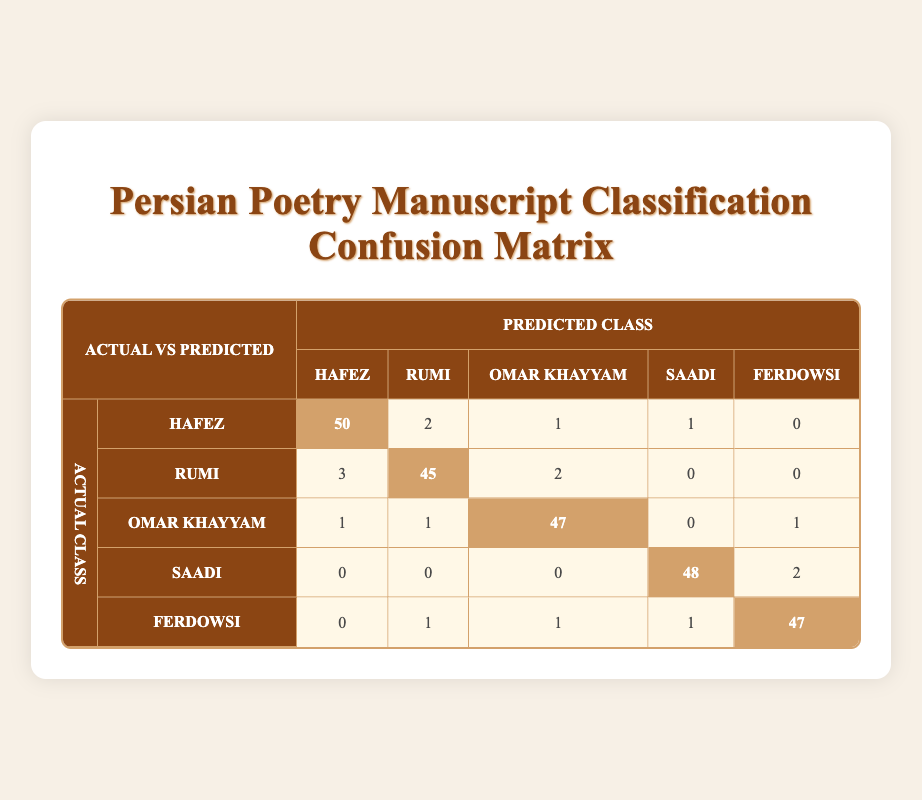What is the count of correctly classified manuscripts for Hafez? The count of correctly classified manuscripts for Hafez is located in the cell corresponding to the actual Hafez row and predicted Hafez column, which indicates 50 manuscripts.
Answer: 50 How many manuscripts of Rumi were misclassified as Hafez? The count of manuscripts of Rumi misclassified as Hafez can be found in the Rumi row and Hafez column, which shows a number of 3.
Answer: 3 What is the total number of manuscripts for Ferdowsi that were classified? To find the total classified manuscripts for Ferdowsi, we sum all values in the Ferdowsi row: 0 (Hafez) + 1 (Rumi) + 1 (Omar Khayyam) + 1 (Saadi) + 47 (Ferdowsi) = 50.
Answer: 50 What percentage of Omar Khayyam manuscripts were correctly classified? The correct classification for Omar Khayyam is the diagonal value, which is 47. To find the percentage, we need to calculate the total compared to its classified manuscripts: the total is 50 (1 + 1 + 47 + 0 + 1). The percentage is (47/50)*100 = 94%.
Answer: 94% Is the number of manuscripts misclassified as Saadi greater than those misclassified as Omar Khayyam? The misclassifications for Saadi are located in the Saadi row and are 0 (Hafez), 0 (Rumi), 0 (Omar Khayyam), 2 (Ferdowsi) totaling 2. For Omar Khayyam, the misclassifications are 1 (Hafez), 1 (Rumi), 0 (Saadi), and 1 (Ferdowsi) totaling 3. Since 2 is less than 3, the statement is false.
Answer: No How many total misclassifications occurred across all poets? To find total misclassifications, calculate all off-diagonal entries: (2 + 1 + 1 + 0) + (3 + 2 + 0 + 0) + (1 + 1 + 0 + 1) + (0 + 0 + 0 + 2) + (0 + 1 + 1 + 1) = 2 + 4 + 3 + 2 + 3 = 14.
Answer: 14 What is the accuracy of the classification for Rumi? The accuracy for Rumi can be calculated as (correctly classified Rumi manuscripts)/(total Rumi manuscripts). From the confusion matrix, out of 50 predicted manuscripts for Rumi, 45 were correct, thus accuracy = 45/50 which equals 0.90 or 90%.
Answer: 90% Among the total manuscripts, which poet had the highest misclassification rate? To determine the poet with the highest misclassification rate, we consider the total misclassifications for each poet and divide by their total manuscripts. Using the previous calculations: Hafez (4 misclass.) out of 55 total, Rumi (5 out of 50), Omar Khayyam (3 out of 50), Saadi (2 out of 50), and Ferdowsi (3 out of 50). Rumi has the highest at 10%. Comparing these rates shows Rumi has the highest misclassification rate.
Answer: Rumi 